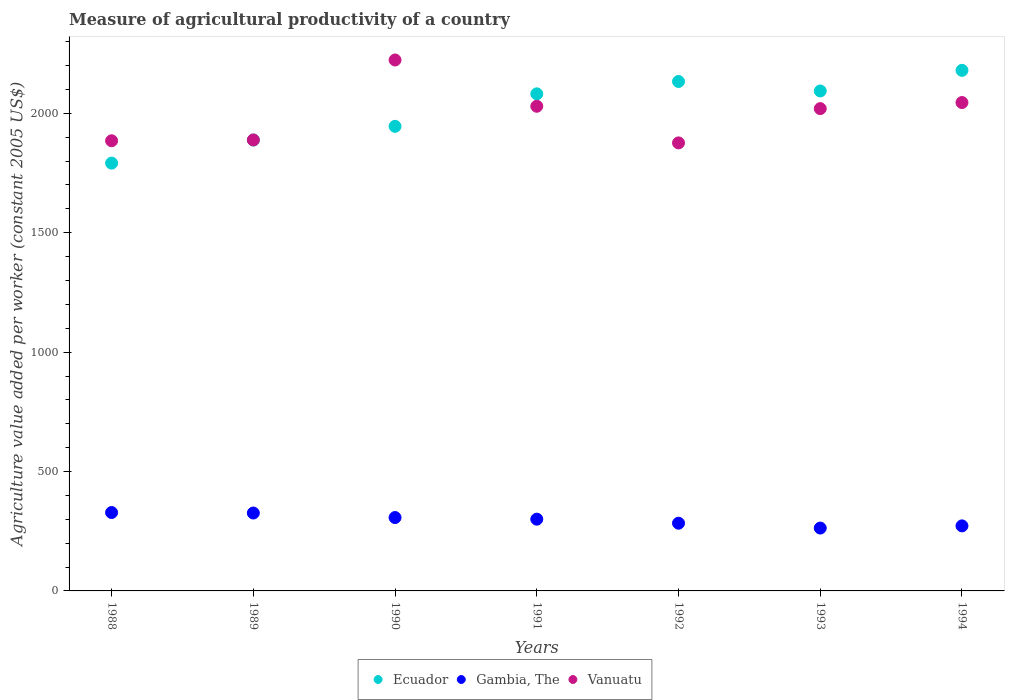What is the measure of agricultural productivity in Vanuatu in 1992?
Keep it short and to the point. 1876.2. Across all years, what is the maximum measure of agricultural productivity in Ecuador?
Your answer should be very brief. 2180.07. Across all years, what is the minimum measure of agricultural productivity in Ecuador?
Provide a short and direct response. 1791.53. What is the total measure of agricultural productivity in Ecuador in the graph?
Your answer should be very brief. 1.41e+04. What is the difference between the measure of agricultural productivity in Ecuador in 1993 and that in 1994?
Give a very brief answer. -86.42. What is the difference between the measure of agricultural productivity in Gambia, The in 1993 and the measure of agricultural productivity in Ecuador in 1991?
Ensure brevity in your answer.  -1818.43. What is the average measure of agricultural productivity in Ecuador per year?
Offer a very short reply. 2016.31. In the year 1991, what is the difference between the measure of agricultural productivity in Gambia, The and measure of agricultural productivity in Ecuador?
Offer a terse response. -1781.17. In how many years, is the measure of agricultural productivity in Gambia, The greater than 200 US$?
Keep it short and to the point. 7. What is the ratio of the measure of agricultural productivity in Gambia, The in 1992 to that in 1993?
Give a very brief answer. 1.08. Is the measure of agricultural productivity in Gambia, The in 1989 less than that in 1994?
Provide a succinct answer. No. What is the difference between the highest and the second highest measure of agricultural productivity in Vanuatu?
Give a very brief answer. 178.23. What is the difference between the highest and the lowest measure of agricultural productivity in Vanuatu?
Your response must be concise. 347.25. In how many years, is the measure of agricultural productivity in Ecuador greater than the average measure of agricultural productivity in Ecuador taken over all years?
Give a very brief answer. 4. Is the sum of the measure of agricultural productivity in Vanuatu in 1991 and 1992 greater than the maximum measure of agricultural productivity in Gambia, The across all years?
Offer a very short reply. Yes. Is it the case that in every year, the sum of the measure of agricultural productivity in Gambia, The and measure of agricultural productivity in Vanuatu  is greater than the measure of agricultural productivity in Ecuador?
Offer a very short reply. Yes. Is the measure of agricultural productivity in Ecuador strictly greater than the measure of agricultural productivity in Gambia, The over the years?
Give a very brief answer. Yes. How many years are there in the graph?
Make the answer very short. 7. Are the values on the major ticks of Y-axis written in scientific E-notation?
Provide a short and direct response. No. Does the graph contain any zero values?
Make the answer very short. No. Does the graph contain grids?
Ensure brevity in your answer.  No. Where does the legend appear in the graph?
Provide a short and direct response. Bottom center. How many legend labels are there?
Provide a short and direct response. 3. What is the title of the graph?
Your response must be concise. Measure of agricultural productivity of a country. Does "Jamaica" appear as one of the legend labels in the graph?
Offer a very short reply. No. What is the label or title of the Y-axis?
Your answer should be compact. Agriculture value added per worker (constant 2005 US$). What is the Agriculture value added per worker (constant 2005 US$) in Ecuador in 1988?
Your answer should be compact. 1791.53. What is the Agriculture value added per worker (constant 2005 US$) in Gambia, The in 1988?
Provide a short and direct response. 328.33. What is the Agriculture value added per worker (constant 2005 US$) of Vanuatu in 1988?
Offer a terse response. 1885.14. What is the Agriculture value added per worker (constant 2005 US$) of Ecuador in 1989?
Ensure brevity in your answer.  1888.3. What is the Agriculture value added per worker (constant 2005 US$) in Gambia, The in 1989?
Your response must be concise. 326.19. What is the Agriculture value added per worker (constant 2005 US$) in Vanuatu in 1989?
Offer a very short reply. 1888.5. What is the Agriculture value added per worker (constant 2005 US$) in Ecuador in 1990?
Your answer should be very brief. 1945.56. What is the Agriculture value added per worker (constant 2005 US$) of Gambia, The in 1990?
Offer a terse response. 307.29. What is the Agriculture value added per worker (constant 2005 US$) of Vanuatu in 1990?
Provide a short and direct response. 2223.45. What is the Agriculture value added per worker (constant 2005 US$) of Ecuador in 1991?
Offer a very short reply. 2081.66. What is the Agriculture value added per worker (constant 2005 US$) of Gambia, The in 1991?
Provide a short and direct response. 300.49. What is the Agriculture value added per worker (constant 2005 US$) in Vanuatu in 1991?
Ensure brevity in your answer.  2029.66. What is the Agriculture value added per worker (constant 2005 US$) in Ecuador in 1992?
Provide a short and direct response. 2133.4. What is the Agriculture value added per worker (constant 2005 US$) in Gambia, The in 1992?
Ensure brevity in your answer.  283.56. What is the Agriculture value added per worker (constant 2005 US$) in Vanuatu in 1992?
Give a very brief answer. 1876.2. What is the Agriculture value added per worker (constant 2005 US$) in Ecuador in 1993?
Offer a very short reply. 2093.64. What is the Agriculture value added per worker (constant 2005 US$) in Gambia, The in 1993?
Your answer should be very brief. 263.23. What is the Agriculture value added per worker (constant 2005 US$) in Vanuatu in 1993?
Your answer should be compact. 2019.75. What is the Agriculture value added per worker (constant 2005 US$) of Ecuador in 1994?
Provide a short and direct response. 2180.07. What is the Agriculture value added per worker (constant 2005 US$) of Gambia, The in 1994?
Your response must be concise. 272.38. What is the Agriculture value added per worker (constant 2005 US$) of Vanuatu in 1994?
Offer a very short reply. 2045.22. Across all years, what is the maximum Agriculture value added per worker (constant 2005 US$) of Ecuador?
Offer a very short reply. 2180.07. Across all years, what is the maximum Agriculture value added per worker (constant 2005 US$) in Gambia, The?
Keep it short and to the point. 328.33. Across all years, what is the maximum Agriculture value added per worker (constant 2005 US$) in Vanuatu?
Offer a very short reply. 2223.45. Across all years, what is the minimum Agriculture value added per worker (constant 2005 US$) of Ecuador?
Ensure brevity in your answer.  1791.53. Across all years, what is the minimum Agriculture value added per worker (constant 2005 US$) of Gambia, The?
Keep it short and to the point. 263.23. Across all years, what is the minimum Agriculture value added per worker (constant 2005 US$) of Vanuatu?
Your answer should be very brief. 1876.2. What is the total Agriculture value added per worker (constant 2005 US$) in Ecuador in the graph?
Your answer should be very brief. 1.41e+04. What is the total Agriculture value added per worker (constant 2005 US$) of Gambia, The in the graph?
Your answer should be compact. 2081.47. What is the total Agriculture value added per worker (constant 2005 US$) in Vanuatu in the graph?
Give a very brief answer. 1.40e+04. What is the difference between the Agriculture value added per worker (constant 2005 US$) of Ecuador in 1988 and that in 1989?
Your answer should be very brief. -96.78. What is the difference between the Agriculture value added per worker (constant 2005 US$) of Gambia, The in 1988 and that in 1989?
Provide a succinct answer. 2.14. What is the difference between the Agriculture value added per worker (constant 2005 US$) of Vanuatu in 1988 and that in 1989?
Your answer should be very brief. -3.35. What is the difference between the Agriculture value added per worker (constant 2005 US$) in Ecuador in 1988 and that in 1990?
Make the answer very short. -154.03. What is the difference between the Agriculture value added per worker (constant 2005 US$) in Gambia, The in 1988 and that in 1990?
Your response must be concise. 21.04. What is the difference between the Agriculture value added per worker (constant 2005 US$) in Vanuatu in 1988 and that in 1990?
Offer a terse response. -338.31. What is the difference between the Agriculture value added per worker (constant 2005 US$) in Ecuador in 1988 and that in 1991?
Make the answer very short. -290.13. What is the difference between the Agriculture value added per worker (constant 2005 US$) of Gambia, The in 1988 and that in 1991?
Offer a very short reply. 27.84. What is the difference between the Agriculture value added per worker (constant 2005 US$) in Vanuatu in 1988 and that in 1991?
Offer a terse response. -144.51. What is the difference between the Agriculture value added per worker (constant 2005 US$) in Ecuador in 1988 and that in 1992?
Give a very brief answer. -341.88. What is the difference between the Agriculture value added per worker (constant 2005 US$) in Gambia, The in 1988 and that in 1992?
Provide a succinct answer. 44.77. What is the difference between the Agriculture value added per worker (constant 2005 US$) of Vanuatu in 1988 and that in 1992?
Give a very brief answer. 8.94. What is the difference between the Agriculture value added per worker (constant 2005 US$) of Ecuador in 1988 and that in 1993?
Keep it short and to the point. -302.12. What is the difference between the Agriculture value added per worker (constant 2005 US$) in Gambia, The in 1988 and that in 1993?
Offer a very short reply. 65.1. What is the difference between the Agriculture value added per worker (constant 2005 US$) of Vanuatu in 1988 and that in 1993?
Your response must be concise. -134.61. What is the difference between the Agriculture value added per worker (constant 2005 US$) in Ecuador in 1988 and that in 1994?
Provide a short and direct response. -388.54. What is the difference between the Agriculture value added per worker (constant 2005 US$) of Gambia, The in 1988 and that in 1994?
Ensure brevity in your answer.  55.95. What is the difference between the Agriculture value added per worker (constant 2005 US$) in Vanuatu in 1988 and that in 1994?
Make the answer very short. -160.08. What is the difference between the Agriculture value added per worker (constant 2005 US$) of Ecuador in 1989 and that in 1990?
Your answer should be compact. -57.26. What is the difference between the Agriculture value added per worker (constant 2005 US$) in Gambia, The in 1989 and that in 1990?
Offer a terse response. 18.9. What is the difference between the Agriculture value added per worker (constant 2005 US$) of Vanuatu in 1989 and that in 1990?
Your answer should be very brief. -334.95. What is the difference between the Agriculture value added per worker (constant 2005 US$) of Ecuador in 1989 and that in 1991?
Make the answer very short. -193.36. What is the difference between the Agriculture value added per worker (constant 2005 US$) of Gambia, The in 1989 and that in 1991?
Provide a succinct answer. 25.7. What is the difference between the Agriculture value added per worker (constant 2005 US$) of Vanuatu in 1989 and that in 1991?
Offer a terse response. -141.16. What is the difference between the Agriculture value added per worker (constant 2005 US$) of Ecuador in 1989 and that in 1992?
Offer a terse response. -245.1. What is the difference between the Agriculture value added per worker (constant 2005 US$) of Gambia, The in 1989 and that in 1992?
Provide a short and direct response. 42.63. What is the difference between the Agriculture value added per worker (constant 2005 US$) of Vanuatu in 1989 and that in 1992?
Offer a very short reply. 12.3. What is the difference between the Agriculture value added per worker (constant 2005 US$) in Ecuador in 1989 and that in 1993?
Provide a short and direct response. -205.34. What is the difference between the Agriculture value added per worker (constant 2005 US$) in Gambia, The in 1989 and that in 1993?
Provide a succinct answer. 62.96. What is the difference between the Agriculture value added per worker (constant 2005 US$) of Vanuatu in 1989 and that in 1993?
Your answer should be very brief. -131.25. What is the difference between the Agriculture value added per worker (constant 2005 US$) of Ecuador in 1989 and that in 1994?
Provide a short and direct response. -291.76. What is the difference between the Agriculture value added per worker (constant 2005 US$) of Gambia, The in 1989 and that in 1994?
Make the answer very short. 53.82. What is the difference between the Agriculture value added per worker (constant 2005 US$) of Vanuatu in 1989 and that in 1994?
Offer a terse response. -156.72. What is the difference between the Agriculture value added per worker (constant 2005 US$) in Ecuador in 1990 and that in 1991?
Keep it short and to the point. -136.1. What is the difference between the Agriculture value added per worker (constant 2005 US$) in Gambia, The in 1990 and that in 1991?
Make the answer very short. 6.8. What is the difference between the Agriculture value added per worker (constant 2005 US$) in Vanuatu in 1990 and that in 1991?
Ensure brevity in your answer.  193.79. What is the difference between the Agriculture value added per worker (constant 2005 US$) in Ecuador in 1990 and that in 1992?
Your answer should be very brief. -187.85. What is the difference between the Agriculture value added per worker (constant 2005 US$) in Gambia, The in 1990 and that in 1992?
Offer a terse response. 23.73. What is the difference between the Agriculture value added per worker (constant 2005 US$) in Vanuatu in 1990 and that in 1992?
Your answer should be very brief. 347.25. What is the difference between the Agriculture value added per worker (constant 2005 US$) of Ecuador in 1990 and that in 1993?
Ensure brevity in your answer.  -148.09. What is the difference between the Agriculture value added per worker (constant 2005 US$) of Gambia, The in 1990 and that in 1993?
Keep it short and to the point. 44.06. What is the difference between the Agriculture value added per worker (constant 2005 US$) in Vanuatu in 1990 and that in 1993?
Your response must be concise. 203.7. What is the difference between the Agriculture value added per worker (constant 2005 US$) of Ecuador in 1990 and that in 1994?
Provide a succinct answer. -234.51. What is the difference between the Agriculture value added per worker (constant 2005 US$) of Gambia, The in 1990 and that in 1994?
Make the answer very short. 34.91. What is the difference between the Agriculture value added per worker (constant 2005 US$) in Vanuatu in 1990 and that in 1994?
Offer a very short reply. 178.23. What is the difference between the Agriculture value added per worker (constant 2005 US$) in Ecuador in 1991 and that in 1992?
Give a very brief answer. -51.74. What is the difference between the Agriculture value added per worker (constant 2005 US$) of Gambia, The in 1991 and that in 1992?
Ensure brevity in your answer.  16.93. What is the difference between the Agriculture value added per worker (constant 2005 US$) in Vanuatu in 1991 and that in 1992?
Offer a terse response. 153.46. What is the difference between the Agriculture value added per worker (constant 2005 US$) in Ecuador in 1991 and that in 1993?
Offer a terse response. -11.98. What is the difference between the Agriculture value added per worker (constant 2005 US$) in Gambia, The in 1991 and that in 1993?
Provide a succinct answer. 37.26. What is the difference between the Agriculture value added per worker (constant 2005 US$) of Vanuatu in 1991 and that in 1993?
Keep it short and to the point. 9.9. What is the difference between the Agriculture value added per worker (constant 2005 US$) in Ecuador in 1991 and that in 1994?
Offer a terse response. -98.41. What is the difference between the Agriculture value added per worker (constant 2005 US$) in Gambia, The in 1991 and that in 1994?
Ensure brevity in your answer.  28.12. What is the difference between the Agriculture value added per worker (constant 2005 US$) in Vanuatu in 1991 and that in 1994?
Ensure brevity in your answer.  -15.56. What is the difference between the Agriculture value added per worker (constant 2005 US$) in Ecuador in 1992 and that in 1993?
Ensure brevity in your answer.  39.76. What is the difference between the Agriculture value added per worker (constant 2005 US$) in Gambia, The in 1992 and that in 1993?
Give a very brief answer. 20.33. What is the difference between the Agriculture value added per worker (constant 2005 US$) of Vanuatu in 1992 and that in 1993?
Provide a short and direct response. -143.55. What is the difference between the Agriculture value added per worker (constant 2005 US$) in Ecuador in 1992 and that in 1994?
Make the answer very short. -46.66. What is the difference between the Agriculture value added per worker (constant 2005 US$) of Gambia, The in 1992 and that in 1994?
Offer a terse response. 11.18. What is the difference between the Agriculture value added per worker (constant 2005 US$) of Vanuatu in 1992 and that in 1994?
Your response must be concise. -169.02. What is the difference between the Agriculture value added per worker (constant 2005 US$) in Ecuador in 1993 and that in 1994?
Offer a very short reply. -86.42. What is the difference between the Agriculture value added per worker (constant 2005 US$) in Gambia, The in 1993 and that in 1994?
Keep it short and to the point. -9.15. What is the difference between the Agriculture value added per worker (constant 2005 US$) in Vanuatu in 1993 and that in 1994?
Give a very brief answer. -25.47. What is the difference between the Agriculture value added per worker (constant 2005 US$) of Ecuador in 1988 and the Agriculture value added per worker (constant 2005 US$) of Gambia, The in 1989?
Offer a terse response. 1465.34. What is the difference between the Agriculture value added per worker (constant 2005 US$) of Ecuador in 1988 and the Agriculture value added per worker (constant 2005 US$) of Vanuatu in 1989?
Offer a very short reply. -96.97. What is the difference between the Agriculture value added per worker (constant 2005 US$) of Gambia, The in 1988 and the Agriculture value added per worker (constant 2005 US$) of Vanuatu in 1989?
Offer a very short reply. -1560.17. What is the difference between the Agriculture value added per worker (constant 2005 US$) in Ecuador in 1988 and the Agriculture value added per worker (constant 2005 US$) in Gambia, The in 1990?
Offer a terse response. 1484.24. What is the difference between the Agriculture value added per worker (constant 2005 US$) of Ecuador in 1988 and the Agriculture value added per worker (constant 2005 US$) of Vanuatu in 1990?
Make the answer very short. -431.93. What is the difference between the Agriculture value added per worker (constant 2005 US$) in Gambia, The in 1988 and the Agriculture value added per worker (constant 2005 US$) in Vanuatu in 1990?
Offer a terse response. -1895.12. What is the difference between the Agriculture value added per worker (constant 2005 US$) of Ecuador in 1988 and the Agriculture value added per worker (constant 2005 US$) of Gambia, The in 1991?
Give a very brief answer. 1491.04. What is the difference between the Agriculture value added per worker (constant 2005 US$) in Ecuador in 1988 and the Agriculture value added per worker (constant 2005 US$) in Vanuatu in 1991?
Provide a succinct answer. -238.13. What is the difference between the Agriculture value added per worker (constant 2005 US$) in Gambia, The in 1988 and the Agriculture value added per worker (constant 2005 US$) in Vanuatu in 1991?
Give a very brief answer. -1701.33. What is the difference between the Agriculture value added per worker (constant 2005 US$) of Ecuador in 1988 and the Agriculture value added per worker (constant 2005 US$) of Gambia, The in 1992?
Ensure brevity in your answer.  1507.97. What is the difference between the Agriculture value added per worker (constant 2005 US$) of Ecuador in 1988 and the Agriculture value added per worker (constant 2005 US$) of Vanuatu in 1992?
Your answer should be compact. -84.68. What is the difference between the Agriculture value added per worker (constant 2005 US$) in Gambia, The in 1988 and the Agriculture value added per worker (constant 2005 US$) in Vanuatu in 1992?
Your answer should be very brief. -1547.87. What is the difference between the Agriculture value added per worker (constant 2005 US$) in Ecuador in 1988 and the Agriculture value added per worker (constant 2005 US$) in Gambia, The in 1993?
Your response must be concise. 1528.3. What is the difference between the Agriculture value added per worker (constant 2005 US$) in Ecuador in 1988 and the Agriculture value added per worker (constant 2005 US$) in Vanuatu in 1993?
Keep it short and to the point. -228.23. What is the difference between the Agriculture value added per worker (constant 2005 US$) of Gambia, The in 1988 and the Agriculture value added per worker (constant 2005 US$) of Vanuatu in 1993?
Ensure brevity in your answer.  -1691.42. What is the difference between the Agriculture value added per worker (constant 2005 US$) of Ecuador in 1988 and the Agriculture value added per worker (constant 2005 US$) of Gambia, The in 1994?
Ensure brevity in your answer.  1519.15. What is the difference between the Agriculture value added per worker (constant 2005 US$) in Ecuador in 1988 and the Agriculture value added per worker (constant 2005 US$) in Vanuatu in 1994?
Provide a succinct answer. -253.7. What is the difference between the Agriculture value added per worker (constant 2005 US$) in Gambia, The in 1988 and the Agriculture value added per worker (constant 2005 US$) in Vanuatu in 1994?
Ensure brevity in your answer.  -1716.89. What is the difference between the Agriculture value added per worker (constant 2005 US$) of Ecuador in 1989 and the Agriculture value added per worker (constant 2005 US$) of Gambia, The in 1990?
Give a very brief answer. 1581.02. What is the difference between the Agriculture value added per worker (constant 2005 US$) of Ecuador in 1989 and the Agriculture value added per worker (constant 2005 US$) of Vanuatu in 1990?
Offer a very short reply. -335.15. What is the difference between the Agriculture value added per worker (constant 2005 US$) in Gambia, The in 1989 and the Agriculture value added per worker (constant 2005 US$) in Vanuatu in 1990?
Provide a succinct answer. -1897.26. What is the difference between the Agriculture value added per worker (constant 2005 US$) of Ecuador in 1989 and the Agriculture value added per worker (constant 2005 US$) of Gambia, The in 1991?
Ensure brevity in your answer.  1587.81. What is the difference between the Agriculture value added per worker (constant 2005 US$) of Ecuador in 1989 and the Agriculture value added per worker (constant 2005 US$) of Vanuatu in 1991?
Offer a terse response. -141.35. What is the difference between the Agriculture value added per worker (constant 2005 US$) of Gambia, The in 1989 and the Agriculture value added per worker (constant 2005 US$) of Vanuatu in 1991?
Your answer should be compact. -1703.47. What is the difference between the Agriculture value added per worker (constant 2005 US$) of Ecuador in 1989 and the Agriculture value added per worker (constant 2005 US$) of Gambia, The in 1992?
Provide a succinct answer. 1604.75. What is the difference between the Agriculture value added per worker (constant 2005 US$) of Ecuador in 1989 and the Agriculture value added per worker (constant 2005 US$) of Vanuatu in 1992?
Offer a terse response. 12.1. What is the difference between the Agriculture value added per worker (constant 2005 US$) in Gambia, The in 1989 and the Agriculture value added per worker (constant 2005 US$) in Vanuatu in 1992?
Your answer should be compact. -1550.01. What is the difference between the Agriculture value added per worker (constant 2005 US$) of Ecuador in 1989 and the Agriculture value added per worker (constant 2005 US$) of Gambia, The in 1993?
Your answer should be compact. 1625.07. What is the difference between the Agriculture value added per worker (constant 2005 US$) in Ecuador in 1989 and the Agriculture value added per worker (constant 2005 US$) in Vanuatu in 1993?
Provide a succinct answer. -131.45. What is the difference between the Agriculture value added per worker (constant 2005 US$) in Gambia, The in 1989 and the Agriculture value added per worker (constant 2005 US$) in Vanuatu in 1993?
Your response must be concise. -1693.56. What is the difference between the Agriculture value added per worker (constant 2005 US$) in Ecuador in 1989 and the Agriculture value added per worker (constant 2005 US$) in Gambia, The in 1994?
Offer a terse response. 1615.93. What is the difference between the Agriculture value added per worker (constant 2005 US$) of Ecuador in 1989 and the Agriculture value added per worker (constant 2005 US$) of Vanuatu in 1994?
Offer a terse response. -156.92. What is the difference between the Agriculture value added per worker (constant 2005 US$) of Gambia, The in 1989 and the Agriculture value added per worker (constant 2005 US$) of Vanuatu in 1994?
Your answer should be compact. -1719.03. What is the difference between the Agriculture value added per worker (constant 2005 US$) of Ecuador in 1990 and the Agriculture value added per worker (constant 2005 US$) of Gambia, The in 1991?
Offer a terse response. 1645.07. What is the difference between the Agriculture value added per worker (constant 2005 US$) in Ecuador in 1990 and the Agriculture value added per worker (constant 2005 US$) in Vanuatu in 1991?
Offer a terse response. -84.1. What is the difference between the Agriculture value added per worker (constant 2005 US$) of Gambia, The in 1990 and the Agriculture value added per worker (constant 2005 US$) of Vanuatu in 1991?
Make the answer very short. -1722.37. What is the difference between the Agriculture value added per worker (constant 2005 US$) of Ecuador in 1990 and the Agriculture value added per worker (constant 2005 US$) of Gambia, The in 1992?
Your answer should be very brief. 1662. What is the difference between the Agriculture value added per worker (constant 2005 US$) of Ecuador in 1990 and the Agriculture value added per worker (constant 2005 US$) of Vanuatu in 1992?
Offer a very short reply. 69.36. What is the difference between the Agriculture value added per worker (constant 2005 US$) of Gambia, The in 1990 and the Agriculture value added per worker (constant 2005 US$) of Vanuatu in 1992?
Provide a succinct answer. -1568.91. What is the difference between the Agriculture value added per worker (constant 2005 US$) of Ecuador in 1990 and the Agriculture value added per worker (constant 2005 US$) of Gambia, The in 1993?
Keep it short and to the point. 1682.33. What is the difference between the Agriculture value added per worker (constant 2005 US$) of Ecuador in 1990 and the Agriculture value added per worker (constant 2005 US$) of Vanuatu in 1993?
Your answer should be compact. -74.19. What is the difference between the Agriculture value added per worker (constant 2005 US$) in Gambia, The in 1990 and the Agriculture value added per worker (constant 2005 US$) in Vanuatu in 1993?
Provide a succinct answer. -1712.47. What is the difference between the Agriculture value added per worker (constant 2005 US$) in Ecuador in 1990 and the Agriculture value added per worker (constant 2005 US$) in Gambia, The in 1994?
Your answer should be compact. 1673.18. What is the difference between the Agriculture value added per worker (constant 2005 US$) of Ecuador in 1990 and the Agriculture value added per worker (constant 2005 US$) of Vanuatu in 1994?
Provide a short and direct response. -99.66. What is the difference between the Agriculture value added per worker (constant 2005 US$) in Gambia, The in 1990 and the Agriculture value added per worker (constant 2005 US$) in Vanuatu in 1994?
Your answer should be very brief. -1737.93. What is the difference between the Agriculture value added per worker (constant 2005 US$) of Ecuador in 1991 and the Agriculture value added per worker (constant 2005 US$) of Gambia, The in 1992?
Your answer should be very brief. 1798.1. What is the difference between the Agriculture value added per worker (constant 2005 US$) of Ecuador in 1991 and the Agriculture value added per worker (constant 2005 US$) of Vanuatu in 1992?
Give a very brief answer. 205.46. What is the difference between the Agriculture value added per worker (constant 2005 US$) of Gambia, The in 1991 and the Agriculture value added per worker (constant 2005 US$) of Vanuatu in 1992?
Provide a succinct answer. -1575.71. What is the difference between the Agriculture value added per worker (constant 2005 US$) of Ecuador in 1991 and the Agriculture value added per worker (constant 2005 US$) of Gambia, The in 1993?
Your answer should be compact. 1818.43. What is the difference between the Agriculture value added per worker (constant 2005 US$) of Ecuador in 1991 and the Agriculture value added per worker (constant 2005 US$) of Vanuatu in 1993?
Keep it short and to the point. 61.91. What is the difference between the Agriculture value added per worker (constant 2005 US$) in Gambia, The in 1991 and the Agriculture value added per worker (constant 2005 US$) in Vanuatu in 1993?
Offer a terse response. -1719.26. What is the difference between the Agriculture value added per worker (constant 2005 US$) of Ecuador in 1991 and the Agriculture value added per worker (constant 2005 US$) of Gambia, The in 1994?
Provide a succinct answer. 1809.28. What is the difference between the Agriculture value added per worker (constant 2005 US$) in Ecuador in 1991 and the Agriculture value added per worker (constant 2005 US$) in Vanuatu in 1994?
Ensure brevity in your answer.  36.44. What is the difference between the Agriculture value added per worker (constant 2005 US$) of Gambia, The in 1991 and the Agriculture value added per worker (constant 2005 US$) of Vanuatu in 1994?
Offer a terse response. -1744.73. What is the difference between the Agriculture value added per worker (constant 2005 US$) in Ecuador in 1992 and the Agriculture value added per worker (constant 2005 US$) in Gambia, The in 1993?
Make the answer very short. 1870.17. What is the difference between the Agriculture value added per worker (constant 2005 US$) in Ecuador in 1992 and the Agriculture value added per worker (constant 2005 US$) in Vanuatu in 1993?
Your response must be concise. 113.65. What is the difference between the Agriculture value added per worker (constant 2005 US$) of Gambia, The in 1992 and the Agriculture value added per worker (constant 2005 US$) of Vanuatu in 1993?
Provide a short and direct response. -1736.2. What is the difference between the Agriculture value added per worker (constant 2005 US$) in Ecuador in 1992 and the Agriculture value added per worker (constant 2005 US$) in Gambia, The in 1994?
Ensure brevity in your answer.  1861.03. What is the difference between the Agriculture value added per worker (constant 2005 US$) in Ecuador in 1992 and the Agriculture value added per worker (constant 2005 US$) in Vanuatu in 1994?
Give a very brief answer. 88.18. What is the difference between the Agriculture value added per worker (constant 2005 US$) in Gambia, The in 1992 and the Agriculture value added per worker (constant 2005 US$) in Vanuatu in 1994?
Your response must be concise. -1761.66. What is the difference between the Agriculture value added per worker (constant 2005 US$) in Ecuador in 1993 and the Agriculture value added per worker (constant 2005 US$) in Gambia, The in 1994?
Give a very brief answer. 1821.27. What is the difference between the Agriculture value added per worker (constant 2005 US$) of Ecuador in 1993 and the Agriculture value added per worker (constant 2005 US$) of Vanuatu in 1994?
Offer a very short reply. 48.42. What is the difference between the Agriculture value added per worker (constant 2005 US$) in Gambia, The in 1993 and the Agriculture value added per worker (constant 2005 US$) in Vanuatu in 1994?
Offer a very short reply. -1781.99. What is the average Agriculture value added per worker (constant 2005 US$) of Ecuador per year?
Ensure brevity in your answer.  2016.31. What is the average Agriculture value added per worker (constant 2005 US$) in Gambia, The per year?
Your answer should be very brief. 297.35. What is the average Agriculture value added per worker (constant 2005 US$) of Vanuatu per year?
Keep it short and to the point. 1995.42. In the year 1988, what is the difference between the Agriculture value added per worker (constant 2005 US$) of Ecuador and Agriculture value added per worker (constant 2005 US$) of Gambia, The?
Offer a terse response. 1463.2. In the year 1988, what is the difference between the Agriculture value added per worker (constant 2005 US$) of Ecuador and Agriculture value added per worker (constant 2005 US$) of Vanuatu?
Offer a very short reply. -93.62. In the year 1988, what is the difference between the Agriculture value added per worker (constant 2005 US$) of Gambia, The and Agriculture value added per worker (constant 2005 US$) of Vanuatu?
Provide a short and direct response. -1556.81. In the year 1989, what is the difference between the Agriculture value added per worker (constant 2005 US$) of Ecuador and Agriculture value added per worker (constant 2005 US$) of Gambia, The?
Your response must be concise. 1562.11. In the year 1989, what is the difference between the Agriculture value added per worker (constant 2005 US$) of Ecuador and Agriculture value added per worker (constant 2005 US$) of Vanuatu?
Your response must be concise. -0.2. In the year 1989, what is the difference between the Agriculture value added per worker (constant 2005 US$) in Gambia, The and Agriculture value added per worker (constant 2005 US$) in Vanuatu?
Give a very brief answer. -1562.31. In the year 1990, what is the difference between the Agriculture value added per worker (constant 2005 US$) of Ecuador and Agriculture value added per worker (constant 2005 US$) of Gambia, The?
Make the answer very short. 1638.27. In the year 1990, what is the difference between the Agriculture value added per worker (constant 2005 US$) of Ecuador and Agriculture value added per worker (constant 2005 US$) of Vanuatu?
Make the answer very short. -277.89. In the year 1990, what is the difference between the Agriculture value added per worker (constant 2005 US$) in Gambia, The and Agriculture value added per worker (constant 2005 US$) in Vanuatu?
Offer a terse response. -1916.16. In the year 1991, what is the difference between the Agriculture value added per worker (constant 2005 US$) of Ecuador and Agriculture value added per worker (constant 2005 US$) of Gambia, The?
Provide a short and direct response. 1781.17. In the year 1991, what is the difference between the Agriculture value added per worker (constant 2005 US$) of Ecuador and Agriculture value added per worker (constant 2005 US$) of Vanuatu?
Your answer should be compact. 52. In the year 1991, what is the difference between the Agriculture value added per worker (constant 2005 US$) of Gambia, The and Agriculture value added per worker (constant 2005 US$) of Vanuatu?
Provide a short and direct response. -1729.17. In the year 1992, what is the difference between the Agriculture value added per worker (constant 2005 US$) of Ecuador and Agriculture value added per worker (constant 2005 US$) of Gambia, The?
Offer a terse response. 1849.85. In the year 1992, what is the difference between the Agriculture value added per worker (constant 2005 US$) in Ecuador and Agriculture value added per worker (constant 2005 US$) in Vanuatu?
Your response must be concise. 257.2. In the year 1992, what is the difference between the Agriculture value added per worker (constant 2005 US$) in Gambia, The and Agriculture value added per worker (constant 2005 US$) in Vanuatu?
Make the answer very short. -1592.64. In the year 1993, what is the difference between the Agriculture value added per worker (constant 2005 US$) of Ecuador and Agriculture value added per worker (constant 2005 US$) of Gambia, The?
Your response must be concise. 1830.41. In the year 1993, what is the difference between the Agriculture value added per worker (constant 2005 US$) in Ecuador and Agriculture value added per worker (constant 2005 US$) in Vanuatu?
Ensure brevity in your answer.  73.89. In the year 1993, what is the difference between the Agriculture value added per worker (constant 2005 US$) of Gambia, The and Agriculture value added per worker (constant 2005 US$) of Vanuatu?
Your response must be concise. -1756.52. In the year 1994, what is the difference between the Agriculture value added per worker (constant 2005 US$) in Ecuador and Agriculture value added per worker (constant 2005 US$) in Gambia, The?
Keep it short and to the point. 1907.69. In the year 1994, what is the difference between the Agriculture value added per worker (constant 2005 US$) in Ecuador and Agriculture value added per worker (constant 2005 US$) in Vanuatu?
Your answer should be compact. 134.85. In the year 1994, what is the difference between the Agriculture value added per worker (constant 2005 US$) in Gambia, The and Agriculture value added per worker (constant 2005 US$) in Vanuatu?
Your answer should be compact. -1772.85. What is the ratio of the Agriculture value added per worker (constant 2005 US$) of Ecuador in 1988 to that in 1989?
Offer a very short reply. 0.95. What is the ratio of the Agriculture value added per worker (constant 2005 US$) in Gambia, The in 1988 to that in 1989?
Give a very brief answer. 1.01. What is the ratio of the Agriculture value added per worker (constant 2005 US$) of Vanuatu in 1988 to that in 1989?
Your answer should be compact. 1. What is the ratio of the Agriculture value added per worker (constant 2005 US$) of Ecuador in 1988 to that in 1990?
Give a very brief answer. 0.92. What is the ratio of the Agriculture value added per worker (constant 2005 US$) in Gambia, The in 1988 to that in 1990?
Your answer should be compact. 1.07. What is the ratio of the Agriculture value added per worker (constant 2005 US$) of Vanuatu in 1988 to that in 1990?
Provide a succinct answer. 0.85. What is the ratio of the Agriculture value added per worker (constant 2005 US$) in Ecuador in 1988 to that in 1991?
Ensure brevity in your answer.  0.86. What is the ratio of the Agriculture value added per worker (constant 2005 US$) of Gambia, The in 1988 to that in 1991?
Make the answer very short. 1.09. What is the ratio of the Agriculture value added per worker (constant 2005 US$) in Vanuatu in 1988 to that in 1991?
Offer a terse response. 0.93. What is the ratio of the Agriculture value added per worker (constant 2005 US$) in Ecuador in 1988 to that in 1992?
Give a very brief answer. 0.84. What is the ratio of the Agriculture value added per worker (constant 2005 US$) of Gambia, The in 1988 to that in 1992?
Offer a very short reply. 1.16. What is the ratio of the Agriculture value added per worker (constant 2005 US$) of Vanuatu in 1988 to that in 1992?
Your response must be concise. 1. What is the ratio of the Agriculture value added per worker (constant 2005 US$) of Ecuador in 1988 to that in 1993?
Keep it short and to the point. 0.86. What is the ratio of the Agriculture value added per worker (constant 2005 US$) in Gambia, The in 1988 to that in 1993?
Your answer should be very brief. 1.25. What is the ratio of the Agriculture value added per worker (constant 2005 US$) in Vanuatu in 1988 to that in 1993?
Provide a succinct answer. 0.93. What is the ratio of the Agriculture value added per worker (constant 2005 US$) in Ecuador in 1988 to that in 1994?
Provide a succinct answer. 0.82. What is the ratio of the Agriculture value added per worker (constant 2005 US$) in Gambia, The in 1988 to that in 1994?
Keep it short and to the point. 1.21. What is the ratio of the Agriculture value added per worker (constant 2005 US$) of Vanuatu in 1988 to that in 1994?
Your answer should be compact. 0.92. What is the ratio of the Agriculture value added per worker (constant 2005 US$) in Ecuador in 1989 to that in 1990?
Offer a terse response. 0.97. What is the ratio of the Agriculture value added per worker (constant 2005 US$) of Gambia, The in 1989 to that in 1990?
Give a very brief answer. 1.06. What is the ratio of the Agriculture value added per worker (constant 2005 US$) in Vanuatu in 1989 to that in 1990?
Offer a terse response. 0.85. What is the ratio of the Agriculture value added per worker (constant 2005 US$) in Ecuador in 1989 to that in 1991?
Ensure brevity in your answer.  0.91. What is the ratio of the Agriculture value added per worker (constant 2005 US$) of Gambia, The in 1989 to that in 1991?
Keep it short and to the point. 1.09. What is the ratio of the Agriculture value added per worker (constant 2005 US$) in Vanuatu in 1989 to that in 1991?
Make the answer very short. 0.93. What is the ratio of the Agriculture value added per worker (constant 2005 US$) in Ecuador in 1989 to that in 1992?
Ensure brevity in your answer.  0.89. What is the ratio of the Agriculture value added per worker (constant 2005 US$) of Gambia, The in 1989 to that in 1992?
Your answer should be compact. 1.15. What is the ratio of the Agriculture value added per worker (constant 2005 US$) of Vanuatu in 1989 to that in 1992?
Offer a very short reply. 1.01. What is the ratio of the Agriculture value added per worker (constant 2005 US$) of Ecuador in 1989 to that in 1993?
Your response must be concise. 0.9. What is the ratio of the Agriculture value added per worker (constant 2005 US$) in Gambia, The in 1989 to that in 1993?
Give a very brief answer. 1.24. What is the ratio of the Agriculture value added per worker (constant 2005 US$) in Vanuatu in 1989 to that in 1993?
Make the answer very short. 0.94. What is the ratio of the Agriculture value added per worker (constant 2005 US$) in Ecuador in 1989 to that in 1994?
Provide a succinct answer. 0.87. What is the ratio of the Agriculture value added per worker (constant 2005 US$) in Gambia, The in 1989 to that in 1994?
Your answer should be compact. 1.2. What is the ratio of the Agriculture value added per worker (constant 2005 US$) in Vanuatu in 1989 to that in 1994?
Keep it short and to the point. 0.92. What is the ratio of the Agriculture value added per worker (constant 2005 US$) of Ecuador in 1990 to that in 1991?
Give a very brief answer. 0.93. What is the ratio of the Agriculture value added per worker (constant 2005 US$) in Gambia, The in 1990 to that in 1991?
Give a very brief answer. 1.02. What is the ratio of the Agriculture value added per worker (constant 2005 US$) of Vanuatu in 1990 to that in 1991?
Make the answer very short. 1.1. What is the ratio of the Agriculture value added per worker (constant 2005 US$) of Ecuador in 1990 to that in 1992?
Keep it short and to the point. 0.91. What is the ratio of the Agriculture value added per worker (constant 2005 US$) of Gambia, The in 1990 to that in 1992?
Give a very brief answer. 1.08. What is the ratio of the Agriculture value added per worker (constant 2005 US$) of Vanuatu in 1990 to that in 1992?
Your response must be concise. 1.19. What is the ratio of the Agriculture value added per worker (constant 2005 US$) in Ecuador in 1990 to that in 1993?
Your answer should be compact. 0.93. What is the ratio of the Agriculture value added per worker (constant 2005 US$) in Gambia, The in 1990 to that in 1993?
Give a very brief answer. 1.17. What is the ratio of the Agriculture value added per worker (constant 2005 US$) in Vanuatu in 1990 to that in 1993?
Provide a short and direct response. 1.1. What is the ratio of the Agriculture value added per worker (constant 2005 US$) of Ecuador in 1990 to that in 1994?
Offer a very short reply. 0.89. What is the ratio of the Agriculture value added per worker (constant 2005 US$) of Gambia, The in 1990 to that in 1994?
Ensure brevity in your answer.  1.13. What is the ratio of the Agriculture value added per worker (constant 2005 US$) in Vanuatu in 1990 to that in 1994?
Give a very brief answer. 1.09. What is the ratio of the Agriculture value added per worker (constant 2005 US$) in Ecuador in 1991 to that in 1992?
Your answer should be very brief. 0.98. What is the ratio of the Agriculture value added per worker (constant 2005 US$) of Gambia, The in 1991 to that in 1992?
Provide a succinct answer. 1.06. What is the ratio of the Agriculture value added per worker (constant 2005 US$) of Vanuatu in 1991 to that in 1992?
Ensure brevity in your answer.  1.08. What is the ratio of the Agriculture value added per worker (constant 2005 US$) of Ecuador in 1991 to that in 1993?
Offer a terse response. 0.99. What is the ratio of the Agriculture value added per worker (constant 2005 US$) in Gambia, The in 1991 to that in 1993?
Give a very brief answer. 1.14. What is the ratio of the Agriculture value added per worker (constant 2005 US$) in Ecuador in 1991 to that in 1994?
Offer a very short reply. 0.95. What is the ratio of the Agriculture value added per worker (constant 2005 US$) of Gambia, The in 1991 to that in 1994?
Give a very brief answer. 1.1. What is the ratio of the Agriculture value added per worker (constant 2005 US$) of Ecuador in 1992 to that in 1993?
Give a very brief answer. 1.02. What is the ratio of the Agriculture value added per worker (constant 2005 US$) in Gambia, The in 1992 to that in 1993?
Provide a short and direct response. 1.08. What is the ratio of the Agriculture value added per worker (constant 2005 US$) of Vanuatu in 1992 to that in 1993?
Give a very brief answer. 0.93. What is the ratio of the Agriculture value added per worker (constant 2005 US$) of Ecuador in 1992 to that in 1994?
Provide a short and direct response. 0.98. What is the ratio of the Agriculture value added per worker (constant 2005 US$) in Gambia, The in 1992 to that in 1994?
Offer a terse response. 1.04. What is the ratio of the Agriculture value added per worker (constant 2005 US$) of Vanuatu in 1992 to that in 1994?
Provide a succinct answer. 0.92. What is the ratio of the Agriculture value added per worker (constant 2005 US$) in Ecuador in 1993 to that in 1994?
Offer a very short reply. 0.96. What is the ratio of the Agriculture value added per worker (constant 2005 US$) of Gambia, The in 1993 to that in 1994?
Your answer should be compact. 0.97. What is the ratio of the Agriculture value added per worker (constant 2005 US$) in Vanuatu in 1993 to that in 1994?
Provide a short and direct response. 0.99. What is the difference between the highest and the second highest Agriculture value added per worker (constant 2005 US$) in Ecuador?
Offer a terse response. 46.66. What is the difference between the highest and the second highest Agriculture value added per worker (constant 2005 US$) of Gambia, The?
Provide a succinct answer. 2.14. What is the difference between the highest and the second highest Agriculture value added per worker (constant 2005 US$) of Vanuatu?
Provide a succinct answer. 178.23. What is the difference between the highest and the lowest Agriculture value added per worker (constant 2005 US$) of Ecuador?
Provide a succinct answer. 388.54. What is the difference between the highest and the lowest Agriculture value added per worker (constant 2005 US$) in Gambia, The?
Make the answer very short. 65.1. What is the difference between the highest and the lowest Agriculture value added per worker (constant 2005 US$) in Vanuatu?
Provide a short and direct response. 347.25. 